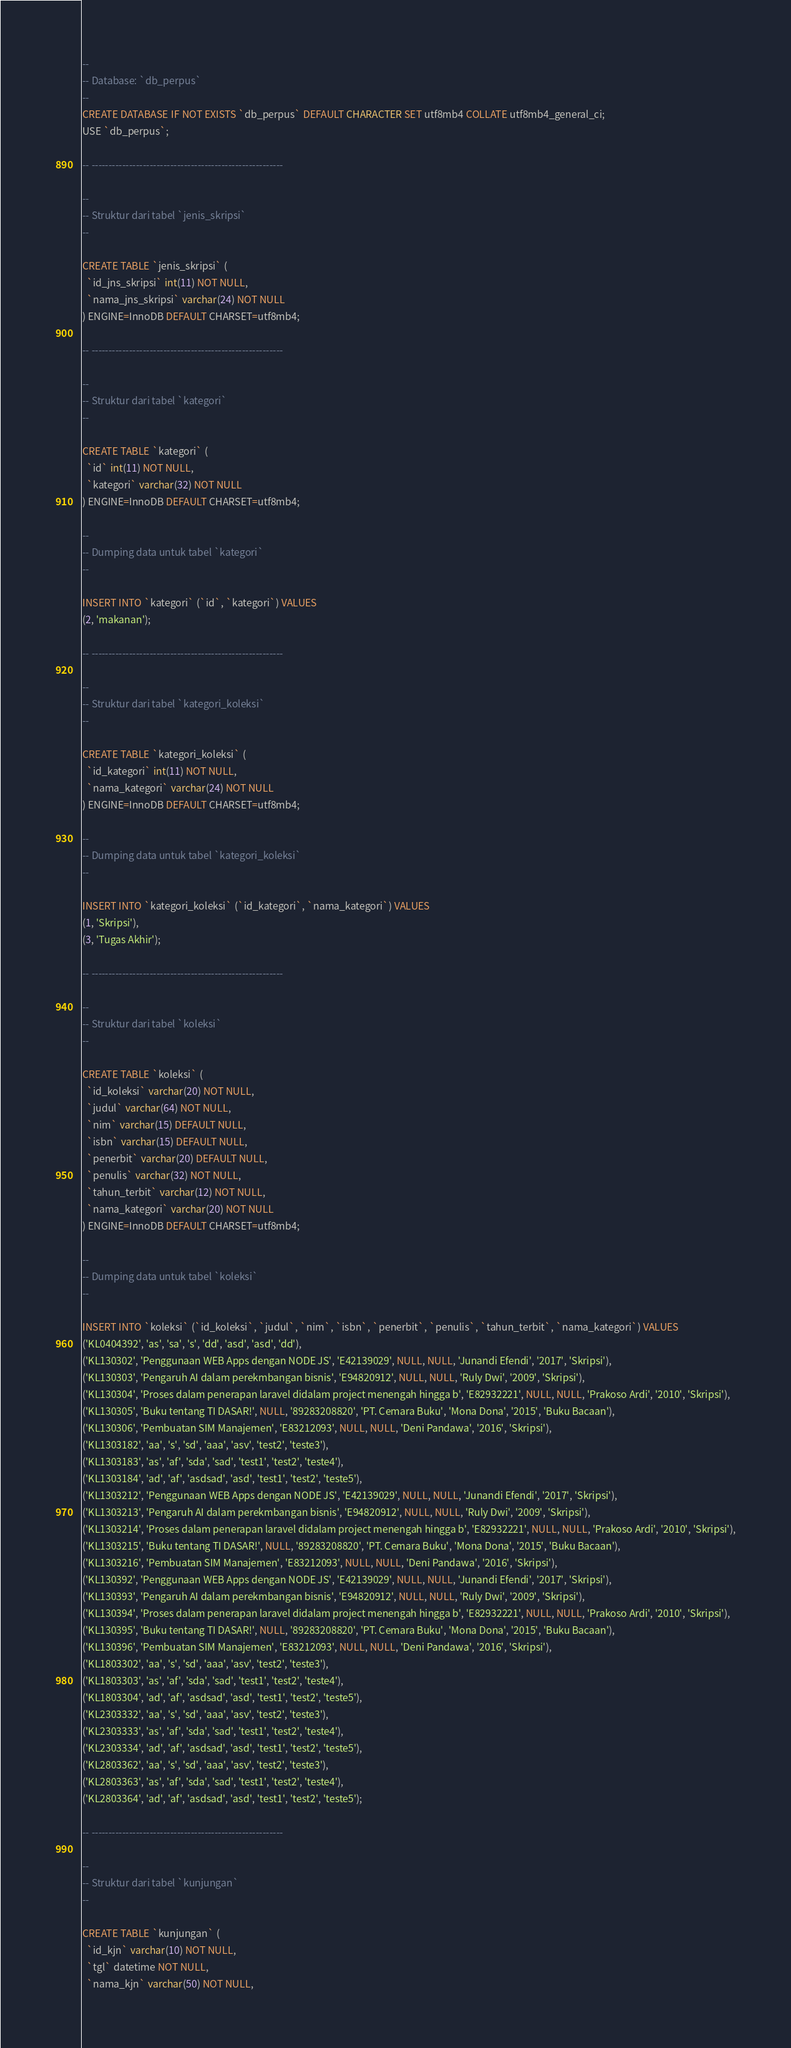Convert code to text. <code><loc_0><loc_0><loc_500><loc_500><_SQL_>--
-- Database: `db_perpus`
--
CREATE DATABASE IF NOT EXISTS `db_perpus` DEFAULT CHARACTER SET utf8mb4 COLLATE utf8mb4_general_ci;
USE `db_perpus`;

-- --------------------------------------------------------

--
-- Struktur dari tabel `jenis_skripsi`
--

CREATE TABLE `jenis_skripsi` (
  `id_jns_skripsi` int(11) NOT NULL,
  `nama_jns_skripsi` varchar(24) NOT NULL
) ENGINE=InnoDB DEFAULT CHARSET=utf8mb4;

-- --------------------------------------------------------

--
-- Struktur dari tabel `kategori`
--

CREATE TABLE `kategori` (
  `id` int(11) NOT NULL,
  `kategori` varchar(32) NOT NULL
) ENGINE=InnoDB DEFAULT CHARSET=utf8mb4;

--
-- Dumping data untuk tabel `kategori`
--

INSERT INTO `kategori` (`id`, `kategori`) VALUES
(2, 'makanan');

-- --------------------------------------------------------

--
-- Struktur dari tabel `kategori_koleksi`
--

CREATE TABLE `kategori_koleksi` (
  `id_kategori` int(11) NOT NULL,
  `nama_kategori` varchar(24) NOT NULL
) ENGINE=InnoDB DEFAULT CHARSET=utf8mb4;

--
-- Dumping data untuk tabel `kategori_koleksi`
--

INSERT INTO `kategori_koleksi` (`id_kategori`, `nama_kategori`) VALUES
(1, 'Skripsi'),
(3, 'Tugas Akhir');

-- --------------------------------------------------------

--
-- Struktur dari tabel `koleksi`
--

CREATE TABLE `koleksi` (
  `id_koleksi` varchar(20) NOT NULL,
  `judul` varchar(64) NOT NULL,
  `nim` varchar(15) DEFAULT NULL,
  `isbn` varchar(15) DEFAULT NULL,
  `penerbit` varchar(20) DEFAULT NULL,
  `penulis` varchar(32) NOT NULL,
  `tahun_terbit` varchar(12) NOT NULL,
  `nama_kategori` varchar(20) NOT NULL
) ENGINE=InnoDB DEFAULT CHARSET=utf8mb4;

--
-- Dumping data untuk tabel `koleksi`
--

INSERT INTO `koleksi` (`id_koleksi`, `judul`, `nim`, `isbn`, `penerbit`, `penulis`, `tahun_terbit`, `nama_kategori`) VALUES
('KL0404392', 'as', 'sa', 's', 'dd', 'asd', 'asd', 'dd'),
('KL130302', 'Penggunaan WEB Apps dengan NODE JS', 'E42139029', NULL, NULL, 'Junandi Efendi', '2017', 'Skripsi'),
('KL130303', 'Pengaruh AI dalam perekmbangan bisnis', 'E94820912', NULL, NULL, 'Ruly Dwi', '2009', 'Skripsi'),
('KL130304', 'Proses dalam penerapan laravel didalam project menengah hingga b', 'E82932221', NULL, NULL, 'Prakoso Ardi', '2010', 'Skripsi'),
('KL130305', 'Buku tentang TI DASAR!', NULL, '89283208820', 'PT. Cemara Buku', 'Mona Dona', '2015', 'Buku Bacaan'),
('KL130306', 'Pembuatan SIM Manajemen', 'E83212093', NULL, NULL, 'Deni Pandawa', '2016', 'Skripsi'),
('KL1303182', 'aa', 's', 'sd', 'aaa', 'asv', 'test2', 'teste3'),
('KL1303183', 'as', 'af', 'sda', 'sad', 'test1', 'test2', 'teste4'),
('KL1303184', 'ad', 'af', 'asdsad', 'asd', 'test1', 'test2', 'teste5'),
('KL1303212', 'Penggunaan WEB Apps dengan NODE JS', 'E42139029', NULL, NULL, 'Junandi Efendi', '2017', 'Skripsi'),
('KL1303213', 'Pengaruh AI dalam perekmbangan bisnis', 'E94820912', NULL, NULL, 'Ruly Dwi', '2009', 'Skripsi'),
('KL1303214', 'Proses dalam penerapan laravel didalam project menengah hingga b', 'E82932221', NULL, NULL, 'Prakoso Ardi', '2010', 'Skripsi'),
('KL1303215', 'Buku tentang TI DASAR!', NULL, '89283208820', 'PT. Cemara Buku', 'Mona Dona', '2015', 'Buku Bacaan'),
('KL1303216', 'Pembuatan SIM Manajemen', 'E83212093', NULL, NULL, 'Deni Pandawa', '2016', 'Skripsi'),
('KL130392', 'Penggunaan WEB Apps dengan NODE JS', 'E42139029', NULL, NULL, 'Junandi Efendi', '2017', 'Skripsi'),
('KL130393', 'Pengaruh AI dalam perekmbangan bisnis', 'E94820912', NULL, NULL, 'Ruly Dwi', '2009', 'Skripsi'),
('KL130394', 'Proses dalam penerapan laravel didalam project menengah hingga b', 'E82932221', NULL, NULL, 'Prakoso Ardi', '2010', 'Skripsi'),
('KL130395', 'Buku tentang TI DASAR!', NULL, '89283208820', 'PT. Cemara Buku', 'Mona Dona', '2015', 'Buku Bacaan'),
('KL130396', 'Pembuatan SIM Manajemen', 'E83212093', NULL, NULL, 'Deni Pandawa', '2016', 'Skripsi'),
('KL1803302', 'aa', 's', 'sd', 'aaa', 'asv', 'test2', 'teste3'),
('KL1803303', 'as', 'af', 'sda', 'sad', 'test1', 'test2', 'teste4'),
('KL1803304', 'ad', 'af', 'asdsad', 'asd', 'test1', 'test2', 'teste5'),
('KL2303332', 'aa', 's', 'sd', 'aaa', 'asv', 'test2', 'teste3'),
('KL2303333', 'as', 'af', 'sda', 'sad', 'test1', 'test2', 'teste4'),
('KL2303334', 'ad', 'af', 'asdsad', 'asd', 'test1', 'test2', 'teste5'),
('KL2803362', 'aa', 's', 'sd', 'aaa', 'asv', 'test2', 'teste3'),
('KL2803363', 'as', 'af', 'sda', 'sad', 'test1', 'test2', 'teste4'),
('KL2803364', 'ad', 'af', 'asdsad', 'asd', 'test1', 'test2', 'teste5');

-- --------------------------------------------------------

--
-- Struktur dari tabel `kunjungan`
--

CREATE TABLE `kunjungan` (
  `id_kjn` varchar(10) NOT NULL,
  `tgl` datetime NOT NULL,
  `nama_kjn` varchar(50) NOT NULL,</code> 